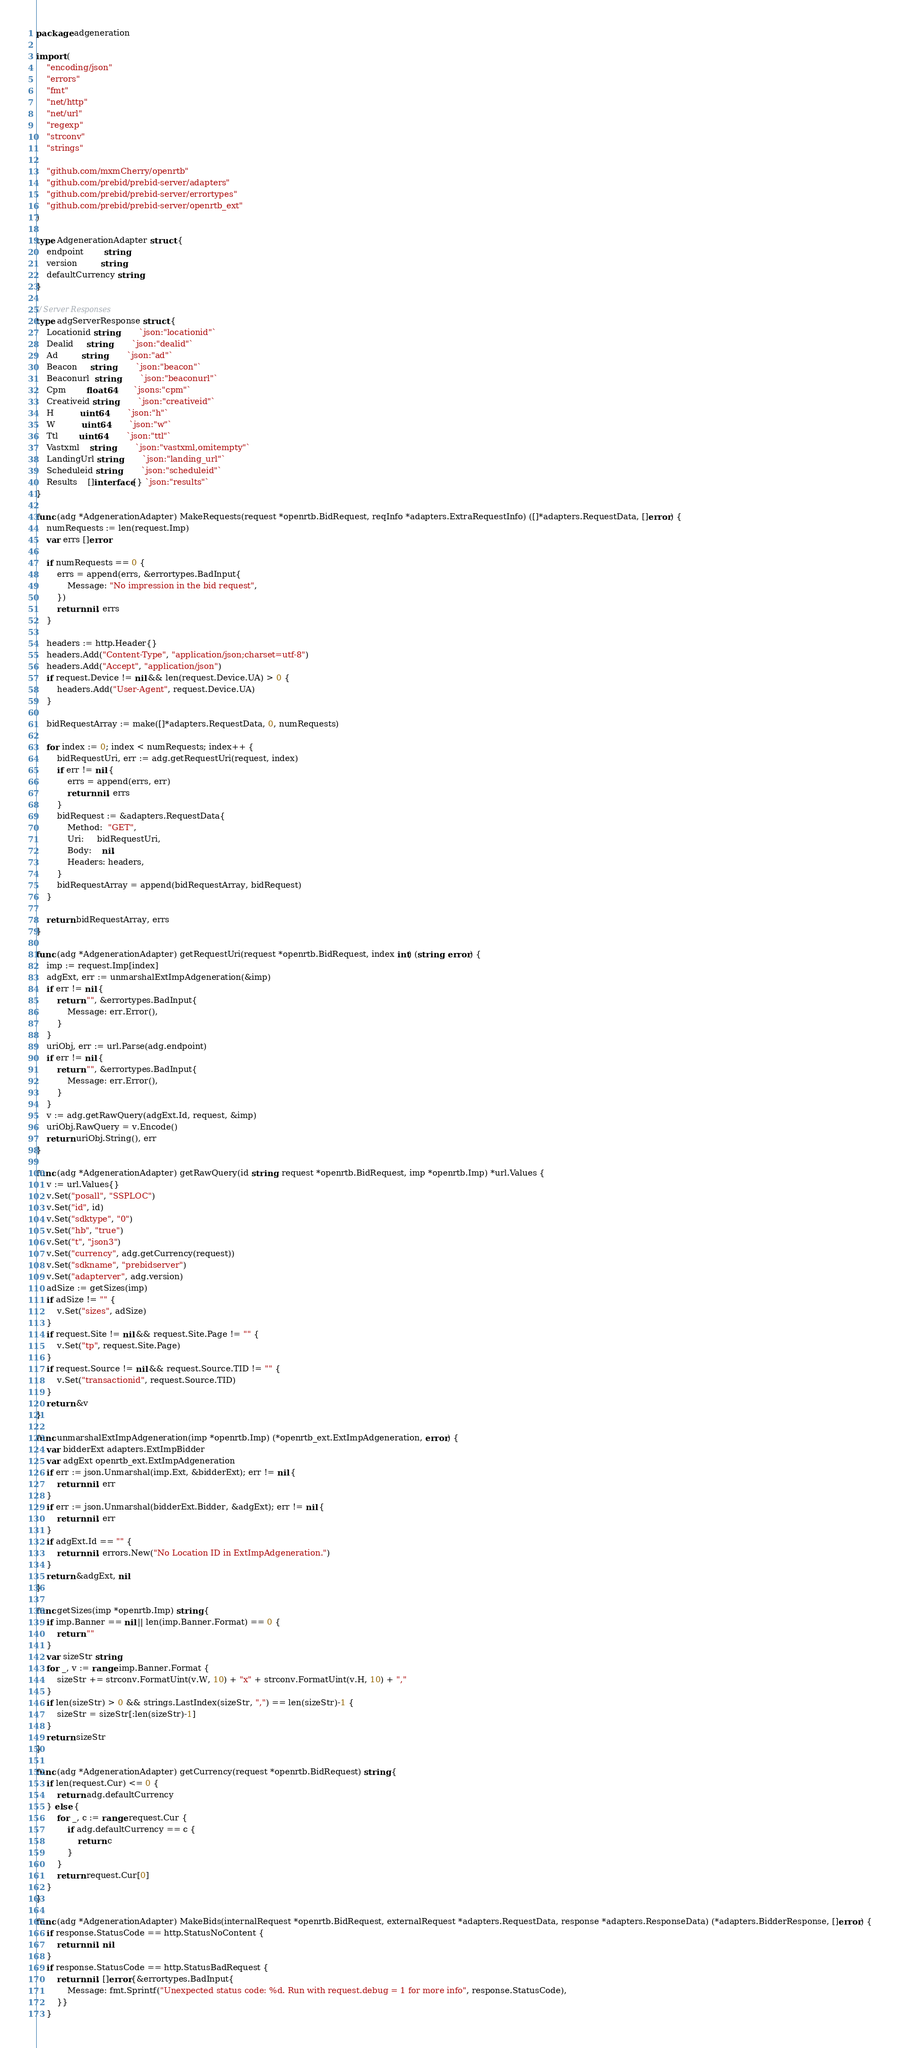Convert code to text. <code><loc_0><loc_0><loc_500><loc_500><_Go_>package adgeneration

import (
	"encoding/json"
	"errors"
	"fmt"
	"net/http"
	"net/url"
	"regexp"
	"strconv"
	"strings"

	"github.com/mxmCherry/openrtb"
	"github.com/prebid/prebid-server/adapters"
	"github.com/prebid/prebid-server/errortypes"
	"github.com/prebid/prebid-server/openrtb_ext"
)

type AdgenerationAdapter struct {
	endpoint        string
	version         string
	defaultCurrency string
}

// Server Responses
type adgServerResponse struct {
	Locationid string        `json:"locationid"`
	Dealid     string        `json:"dealid"`
	Ad         string        `json:"ad"`
	Beacon     string        `json:"beacon"`
	Beaconurl  string        `json:"beaconurl"`
	Cpm        float64       `jsons:"cpm"`
	Creativeid string        `json:"creativeid"`
	H          uint64        `json:"h"`
	W          uint64        `json:"w"`
	Ttl        uint64        `json:"ttl"`
	Vastxml    string        `json:"vastxml,omitempty"`
	LandingUrl string        `json:"landing_url"`
	Scheduleid string        `json:"scheduleid"`
	Results    []interface{} `json:"results"`
}

func (adg *AdgenerationAdapter) MakeRequests(request *openrtb.BidRequest, reqInfo *adapters.ExtraRequestInfo) ([]*adapters.RequestData, []error) {
	numRequests := len(request.Imp)
	var errs []error

	if numRequests == 0 {
		errs = append(errs, &errortypes.BadInput{
			Message: "No impression in the bid request",
		})
		return nil, errs
	}

	headers := http.Header{}
	headers.Add("Content-Type", "application/json;charset=utf-8")
	headers.Add("Accept", "application/json")
	if request.Device != nil && len(request.Device.UA) > 0 {
		headers.Add("User-Agent", request.Device.UA)
	}

	bidRequestArray := make([]*adapters.RequestData, 0, numRequests)

	for index := 0; index < numRequests; index++ {
		bidRequestUri, err := adg.getRequestUri(request, index)
		if err != nil {
			errs = append(errs, err)
			return nil, errs
		}
		bidRequest := &adapters.RequestData{
			Method:  "GET",
			Uri:     bidRequestUri,
			Body:    nil,
			Headers: headers,
		}
		bidRequestArray = append(bidRequestArray, bidRequest)
	}

	return bidRequestArray, errs
}

func (adg *AdgenerationAdapter) getRequestUri(request *openrtb.BidRequest, index int) (string, error) {
	imp := request.Imp[index]
	adgExt, err := unmarshalExtImpAdgeneration(&imp)
	if err != nil {
		return "", &errortypes.BadInput{
			Message: err.Error(),
		}
	}
	uriObj, err := url.Parse(adg.endpoint)
	if err != nil {
		return "", &errortypes.BadInput{
			Message: err.Error(),
		}
	}
	v := adg.getRawQuery(adgExt.Id, request, &imp)
	uriObj.RawQuery = v.Encode()
	return uriObj.String(), err
}

func (adg *AdgenerationAdapter) getRawQuery(id string, request *openrtb.BidRequest, imp *openrtb.Imp) *url.Values {
	v := url.Values{}
	v.Set("posall", "SSPLOC")
	v.Set("id", id)
	v.Set("sdktype", "0")
	v.Set("hb", "true")
	v.Set("t", "json3")
	v.Set("currency", adg.getCurrency(request))
	v.Set("sdkname", "prebidserver")
	v.Set("adapterver", adg.version)
	adSize := getSizes(imp)
	if adSize != "" {
		v.Set("sizes", adSize)
	}
	if request.Site != nil && request.Site.Page != "" {
		v.Set("tp", request.Site.Page)
	}
	if request.Source != nil && request.Source.TID != "" {
		v.Set("transactionid", request.Source.TID)
	}
	return &v
}

func unmarshalExtImpAdgeneration(imp *openrtb.Imp) (*openrtb_ext.ExtImpAdgeneration, error) {
	var bidderExt adapters.ExtImpBidder
	var adgExt openrtb_ext.ExtImpAdgeneration
	if err := json.Unmarshal(imp.Ext, &bidderExt); err != nil {
		return nil, err
	}
	if err := json.Unmarshal(bidderExt.Bidder, &adgExt); err != nil {
		return nil, err
	}
	if adgExt.Id == "" {
		return nil, errors.New("No Location ID in ExtImpAdgeneration.")
	}
	return &adgExt, nil
}

func getSizes(imp *openrtb.Imp) string {
	if imp.Banner == nil || len(imp.Banner.Format) == 0 {
		return ""
	}
	var sizeStr string
	for _, v := range imp.Banner.Format {
		sizeStr += strconv.FormatUint(v.W, 10) + "x" + strconv.FormatUint(v.H, 10) + ","
	}
	if len(sizeStr) > 0 && strings.LastIndex(sizeStr, ",") == len(sizeStr)-1 {
		sizeStr = sizeStr[:len(sizeStr)-1]
	}
	return sizeStr
}

func (adg *AdgenerationAdapter) getCurrency(request *openrtb.BidRequest) string {
	if len(request.Cur) <= 0 {
		return adg.defaultCurrency
	} else {
		for _, c := range request.Cur {
			if adg.defaultCurrency == c {
				return c
			}
		}
		return request.Cur[0]
	}
}

func (adg *AdgenerationAdapter) MakeBids(internalRequest *openrtb.BidRequest, externalRequest *adapters.RequestData, response *adapters.ResponseData) (*adapters.BidderResponse, []error) {
	if response.StatusCode == http.StatusNoContent {
		return nil, nil
	}
	if response.StatusCode == http.StatusBadRequest {
		return nil, []error{&errortypes.BadInput{
			Message: fmt.Sprintf("Unexpected status code: %d. Run with request.debug = 1 for more info", response.StatusCode),
		}}
	}</code> 